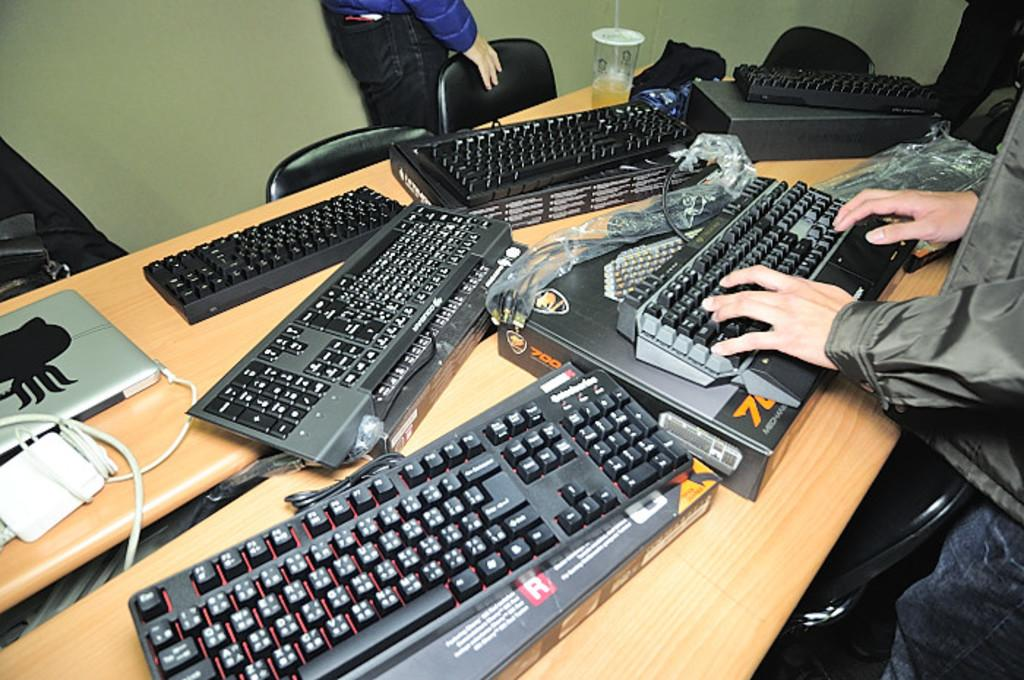<image>
Summarize the visual content of the image. the letter R is on the area under the keyboard 